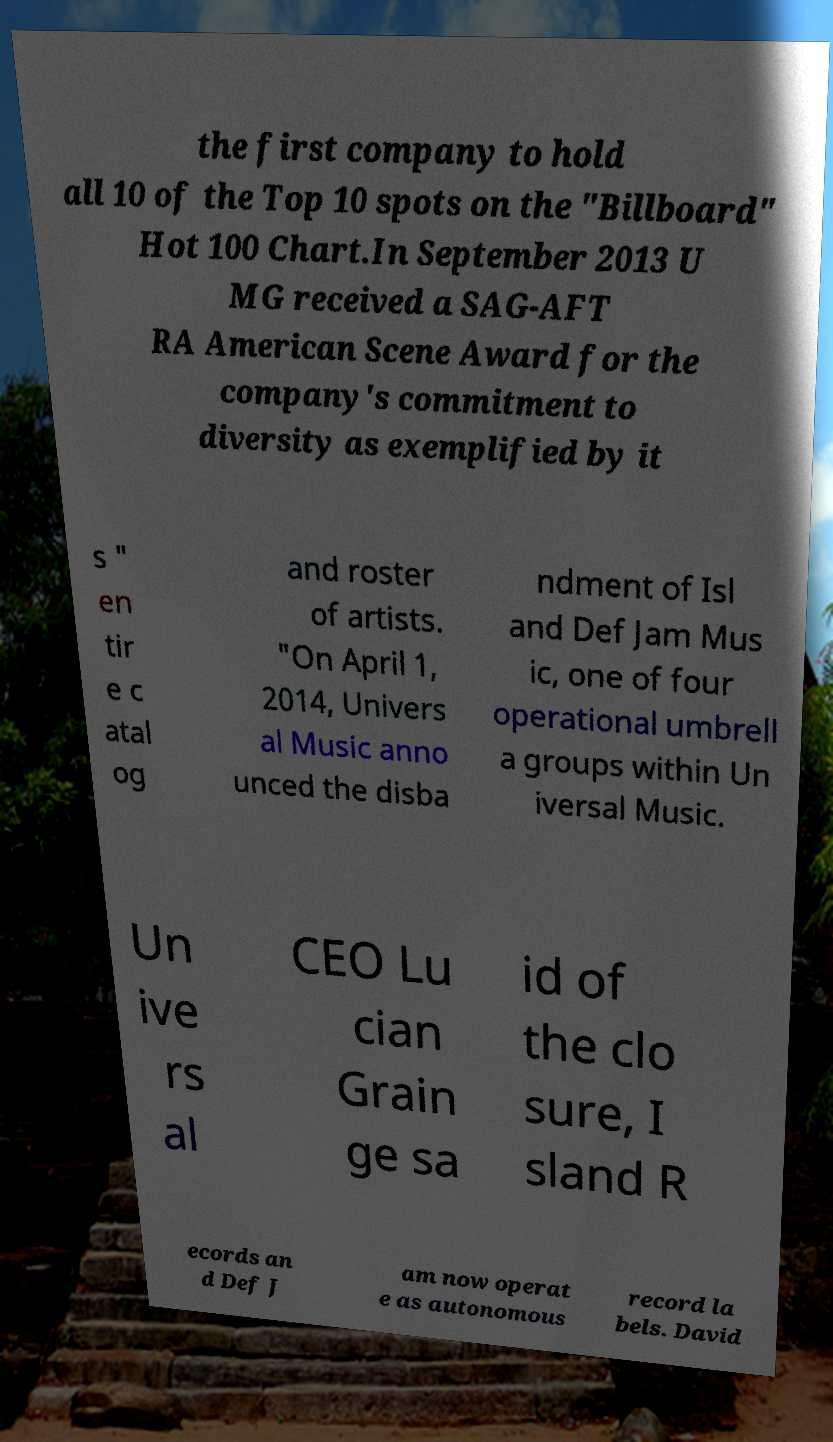I need the written content from this picture converted into text. Can you do that? the first company to hold all 10 of the Top 10 spots on the "Billboard" Hot 100 Chart.In September 2013 U MG received a SAG-AFT RA American Scene Award for the company's commitment to diversity as exemplified by it s " en tir e c atal og and roster of artists. "On April 1, 2014, Univers al Music anno unced the disba ndment of Isl and Def Jam Mus ic, one of four operational umbrell a groups within Un iversal Music. Un ive rs al CEO Lu cian Grain ge sa id of the clo sure, I sland R ecords an d Def J am now operat e as autonomous record la bels. David 